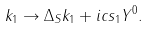Convert formula to latex. <formula><loc_0><loc_0><loc_500><loc_500>k _ { 1 } \rightarrow \Delta _ { S } k _ { 1 } + i c s _ { 1 } Y ^ { 0 } .</formula> 